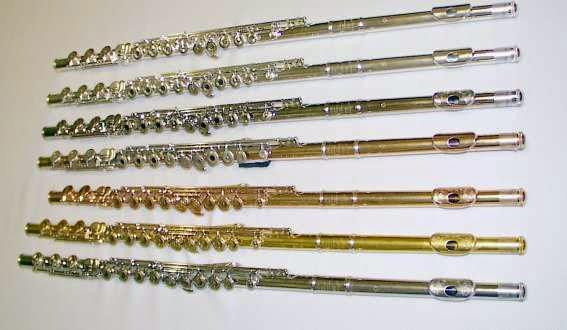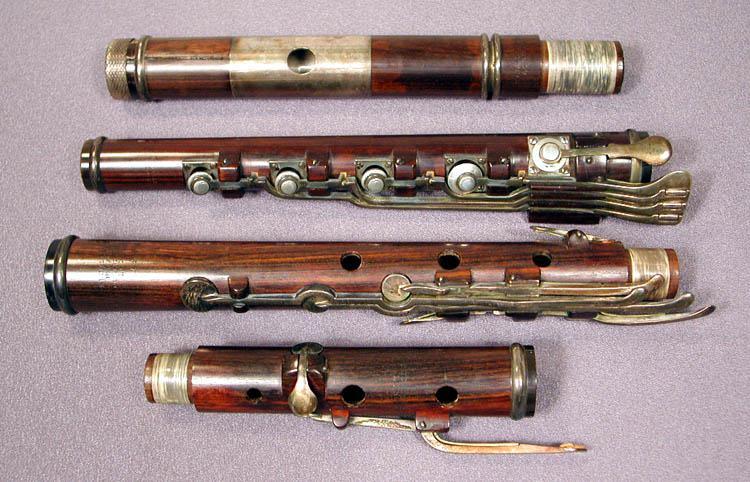The first image is the image on the left, the second image is the image on the right. Analyze the images presented: Is the assertion "The instrument in the image on the right has blue bands on it." valid? Answer yes or no. No. The first image is the image on the left, the second image is the image on the right. For the images displayed, is the sentence "There is a wood flute in the left image." factually correct? Answer yes or no. No. 